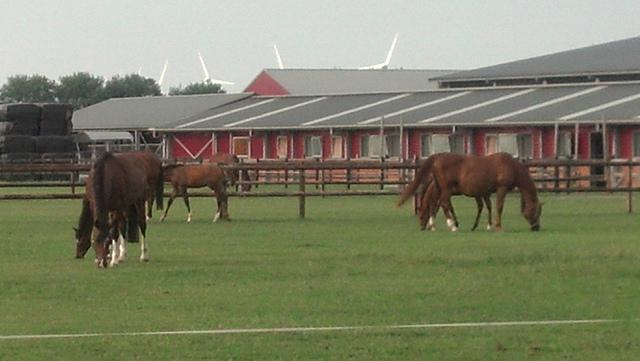Is the horse wearing a coat?
Answer briefly. No. What are the white arms in the background producing?
Keep it brief. Electricity. Do any of the horses have white socks?
Answer briefly. No. What are horses eating?
Quick response, please. Grass. 